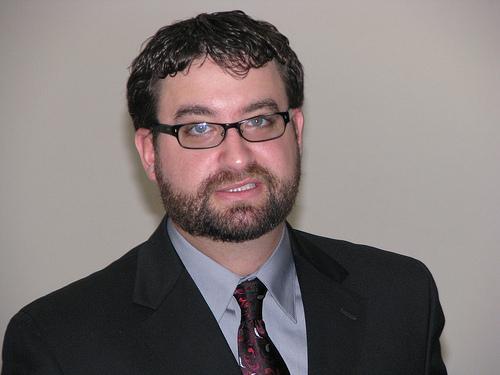How many people are in the picture?
Give a very brief answer. 1. How many people are shown?
Give a very brief answer. 1. 